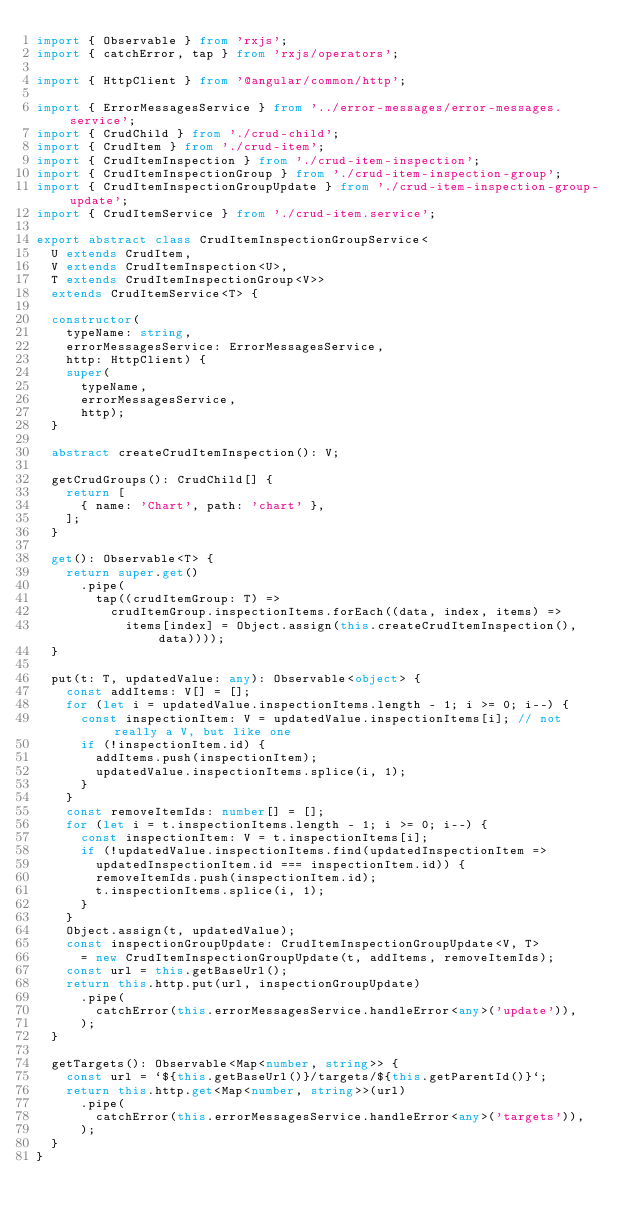<code> <loc_0><loc_0><loc_500><loc_500><_TypeScript_>import { Observable } from 'rxjs';
import { catchError, tap } from 'rxjs/operators';

import { HttpClient } from '@angular/common/http';

import { ErrorMessagesService } from '../error-messages/error-messages.service';
import { CrudChild } from './crud-child';
import { CrudItem } from './crud-item';
import { CrudItemInspection } from './crud-item-inspection';
import { CrudItemInspectionGroup } from './crud-item-inspection-group';
import { CrudItemInspectionGroupUpdate } from './crud-item-inspection-group-update';
import { CrudItemService } from './crud-item.service';

export abstract class CrudItemInspectionGroupService<
  U extends CrudItem,
  V extends CrudItemInspection<U>,
  T extends CrudItemInspectionGroup<V>>
  extends CrudItemService<T> {

  constructor(
    typeName: string,
    errorMessagesService: ErrorMessagesService,
    http: HttpClient) {
    super(
      typeName,
      errorMessagesService,
      http);
  }

  abstract createCrudItemInspection(): V;

  getCrudGroups(): CrudChild[] {
    return [
      { name: 'Chart', path: 'chart' },
    ];
  }

  get(): Observable<T> {
    return super.get()
      .pipe(
        tap((crudItemGroup: T) =>
          crudItemGroup.inspectionItems.forEach((data, index, items) =>
            items[index] = Object.assign(this.createCrudItemInspection(), data))));
  }

  put(t: T, updatedValue: any): Observable<object> {
    const addItems: V[] = [];
    for (let i = updatedValue.inspectionItems.length - 1; i >= 0; i--) {
      const inspectionItem: V = updatedValue.inspectionItems[i]; // not really a V, but like one
      if (!inspectionItem.id) {
        addItems.push(inspectionItem);
        updatedValue.inspectionItems.splice(i, 1);
      }
    }
    const removeItemIds: number[] = [];
    for (let i = t.inspectionItems.length - 1; i >= 0; i--) {
      const inspectionItem: V = t.inspectionItems[i];
      if (!updatedValue.inspectionItems.find(updatedInspectionItem =>
        updatedInspectionItem.id === inspectionItem.id)) {
        removeItemIds.push(inspectionItem.id);
        t.inspectionItems.splice(i, 1);
      }
    }
    Object.assign(t, updatedValue);
    const inspectionGroupUpdate: CrudItemInspectionGroupUpdate<V, T>
      = new CrudItemInspectionGroupUpdate(t, addItems, removeItemIds);
    const url = this.getBaseUrl();
    return this.http.put(url, inspectionGroupUpdate)
      .pipe(
        catchError(this.errorMessagesService.handleError<any>('update')),
      );
  }

  getTargets(): Observable<Map<number, string>> {
    const url = `${this.getBaseUrl()}/targets/${this.getParentId()}`;
    return this.http.get<Map<number, string>>(url)
      .pipe(
        catchError(this.errorMessagesService.handleError<any>('targets')),
      );
  }
}
</code> 